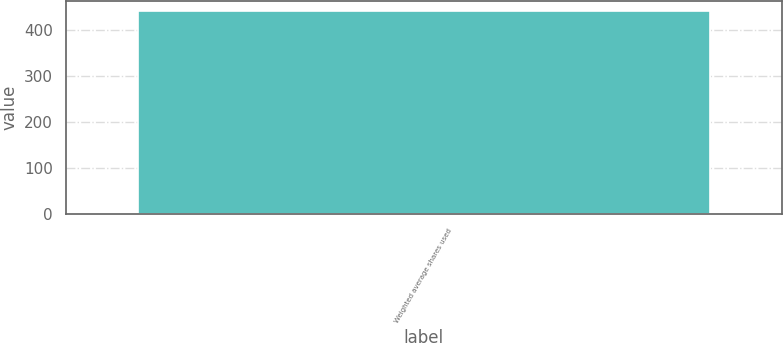Convert chart. <chart><loc_0><loc_0><loc_500><loc_500><bar_chart><fcel>Weighted average shares used<nl><fcel>441<nl></chart> 